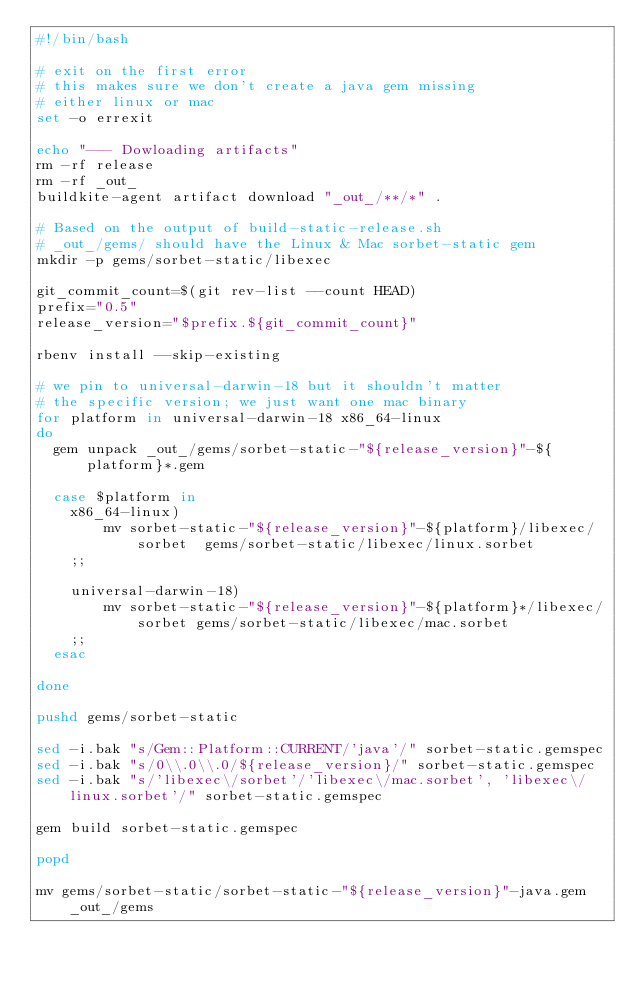<code> <loc_0><loc_0><loc_500><loc_500><_Bash_>#!/bin/bash

# exit on the first error
# this makes sure we don't create a java gem missing
# either linux or mac
set -o errexit

echo "--- Dowloading artifacts"
rm -rf release
rm -rf _out_
buildkite-agent artifact download "_out_/**/*" .

# Based on the output of build-static-release.sh
# _out_/gems/ should have the Linux & Mac sorbet-static gem
mkdir -p gems/sorbet-static/libexec

git_commit_count=$(git rev-list --count HEAD)
prefix="0.5"
release_version="$prefix.${git_commit_count}"

rbenv install --skip-existing

# we pin to universal-darwin-18 but it shouldn't matter
# the specific version; we just want one mac binary
for platform in universal-darwin-18 x86_64-linux
do
  gem unpack _out_/gems/sorbet-static-"${release_version}"-${platform}*.gem

  case $platform in
    x86_64-linux)
        mv sorbet-static-"${release_version}"-${platform}/libexec/sorbet  gems/sorbet-static/libexec/linux.sorbet
    ;;

    universal-darwin-18)
        mv sorbet-static-"${release_version}"-${platform}*/libexec/sorbet gems/sorbet-static/libexec/mac.sorbet
    ;;
  esac

done

pushd gems/sorbet-static

sed -i.bak "s/Gem::Platform::CURRENT/'java'/" sorbet-static.gemspec
sed -i.bak "s/0\\.0\\.0/${release_version}/" sorbet-static.gemspec
sed -i.bak "s/'libexec\/sorbet'/'libexec\/mac.sorbet', 'libexec\/linux.sorbet'/" sorbet-static.gemspec

gem build sorbet-static.gemspec

popd

mv gems/sorbet-static/sorbet-static-"${release_version}"-java.gem _out_/gems
</code> 